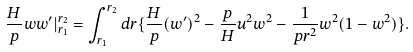Convert formula to latex. <formula><loc_0><loc_0><loc_500><loc_500>\frac { H } { p } w w ^ { \prime } | _ { r _ { 1 } } ^ { r _ { 2 } } = \int _ { r _ { 1 } } ^ { r _ { 2 } } d r \{ \frac { H } { p } ( w ^ { \prime } ) ^ { 2 } - \frac { p } { H } u ^ { 2 } w ^ { 2 } - \frac { 1 } { p r ^ { 2 } } w ^ { 2 } ( 1 - w ^ { 2 } ) \} .</formula> 